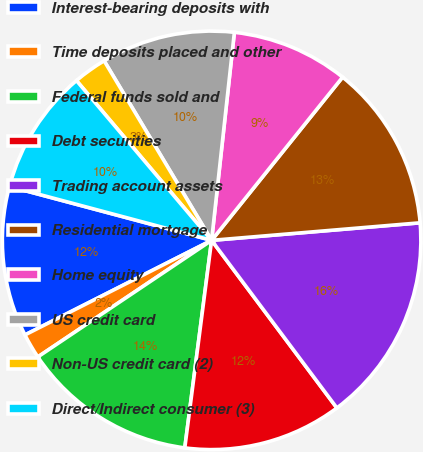<chart> <loc_0><loc_0><loc_500><loc_500><pie_chart><fcel>Interest-bearing deposits with<fcel>Time deposits placed and other<fcel>Federal funds sold and<fcel>Debt securities<fcel>Trading account assets<fcel>Residential mortgage<fcel>Home equity<fcel>US credit card<fcel>Non-US credit card (2)<fcel>Direct/Indirect consumer (3)<nl><fcel>11.61%<fcel>1.94%<fcel>13.55%<fcel>12.26%<fcel>16.12%<fcel>12.9%<fcel>9.03%<fcel>10.32%<fcel>2.59%<fcel>9.68%<nl></chart> 